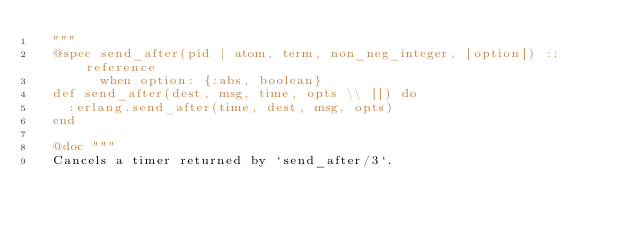Convert code to text. <code><loc_0><loc_0><loc_500><loc_500><_Elixir_>  """
  @spec send_after(pid | atom, term, non_neg_integer, [option]) :: reference
        when option: {:abs, boolean}
  def send_after(dest, msg, time, opts \\ []) do
    :erlang.send_after(time, dest, msg, opts)
  end

  @doc """
  Cancels a timer returned by `send_after/3`.
</code> 